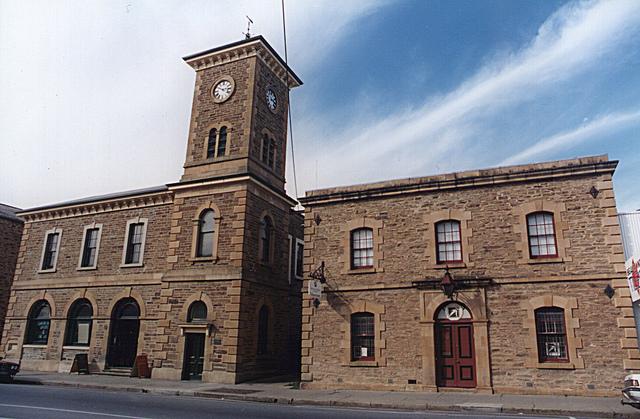What shape are most of the windows?
Short answer required. Rectangle. How many buildings do you see?
Be succinct. 2. What is the building made of?
Answer briefly. Brick. How many sides can you see a clock on?
Write a very short answer. 2. 